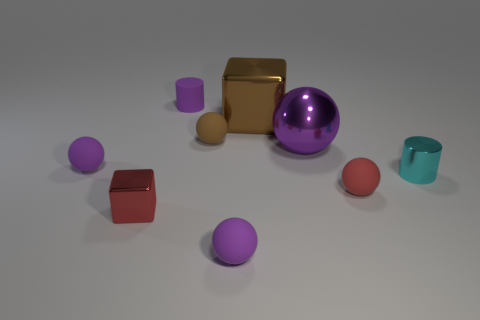Subtract all tiny purple rubber balls. How many balls are left? 3 Subtract all purple spheres. How many spheres are left? 2 Subtract all red blocks. How many purple balls are left? 3 Subtract all yellow spheres. Subtract all green blocks. How many spheres are left? 5 Add 1 balls. How many objects exist? 10 Subtract all cubes. How many objects are left? 7 Subtract all brown metal things. Subtract all cyan cylinders. How many objects are left? 7 Add 2 matte cylinders. How many matte cylinders are left? 3 Add 6 tiny purple objects. How many tiny purple objects exist? 9 Subtract 0 gray cylinders. How many objects are left? 9 